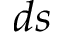Convert formula to latex. <formula><loc_0><loc_0><loc_500><loc_500>d s</formula> 